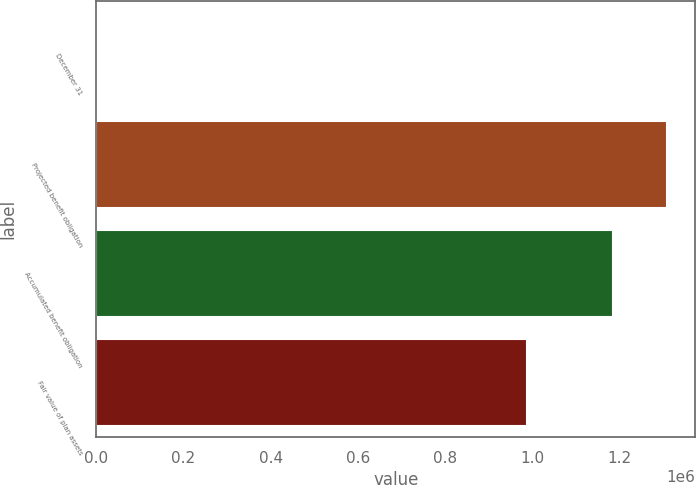<chart> <loc_0><loc_0><loc_500><loc_500><bar_chart><fcel>December 31<fcel>Projected benefit obligation<fcel>Accumulated benefit obligation<fcel>Fair value of plan assets<nl><fcel>2012<fcel>1.30874e+06<fcel>1.18521e+06<fcel>987643<nl></chart> 